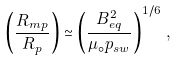Convert formula to latex. <formula><loc_0><loc_0><loc_500><loc_500>\left ( \frac { { R _ { m p } } } { R _ { p } } \right ) \simeq \left ( \frac { B _ { e q } ^ { 2 } } { \mu _ { \circ } { p _ { s w } } } \right ) ^ { 1 / 6 } \, ,</formula> 